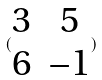<formula> <loc_0><loc_0><loc_500><loc_500>( \begin{matrix} 3 & 5 \\ 6 & - 1 \end{matrix} )</formula> 